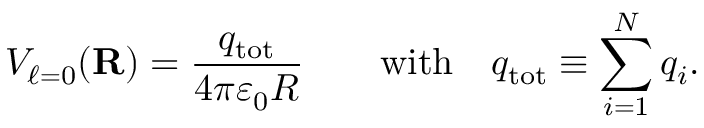Convert formula to latex. <formula><loc_0><loc_0><loc_500><loc_500>V _ { \ell = 0 } ( R ) = { \frac { q _ { t o t } } { 4 \pi \varepsilon _ { 0 } R } } \quad { w i t h } \quad q _ { t o t } \equiv \sum _ { i = 1 } ^ { N } q _ { i } .</formula> 